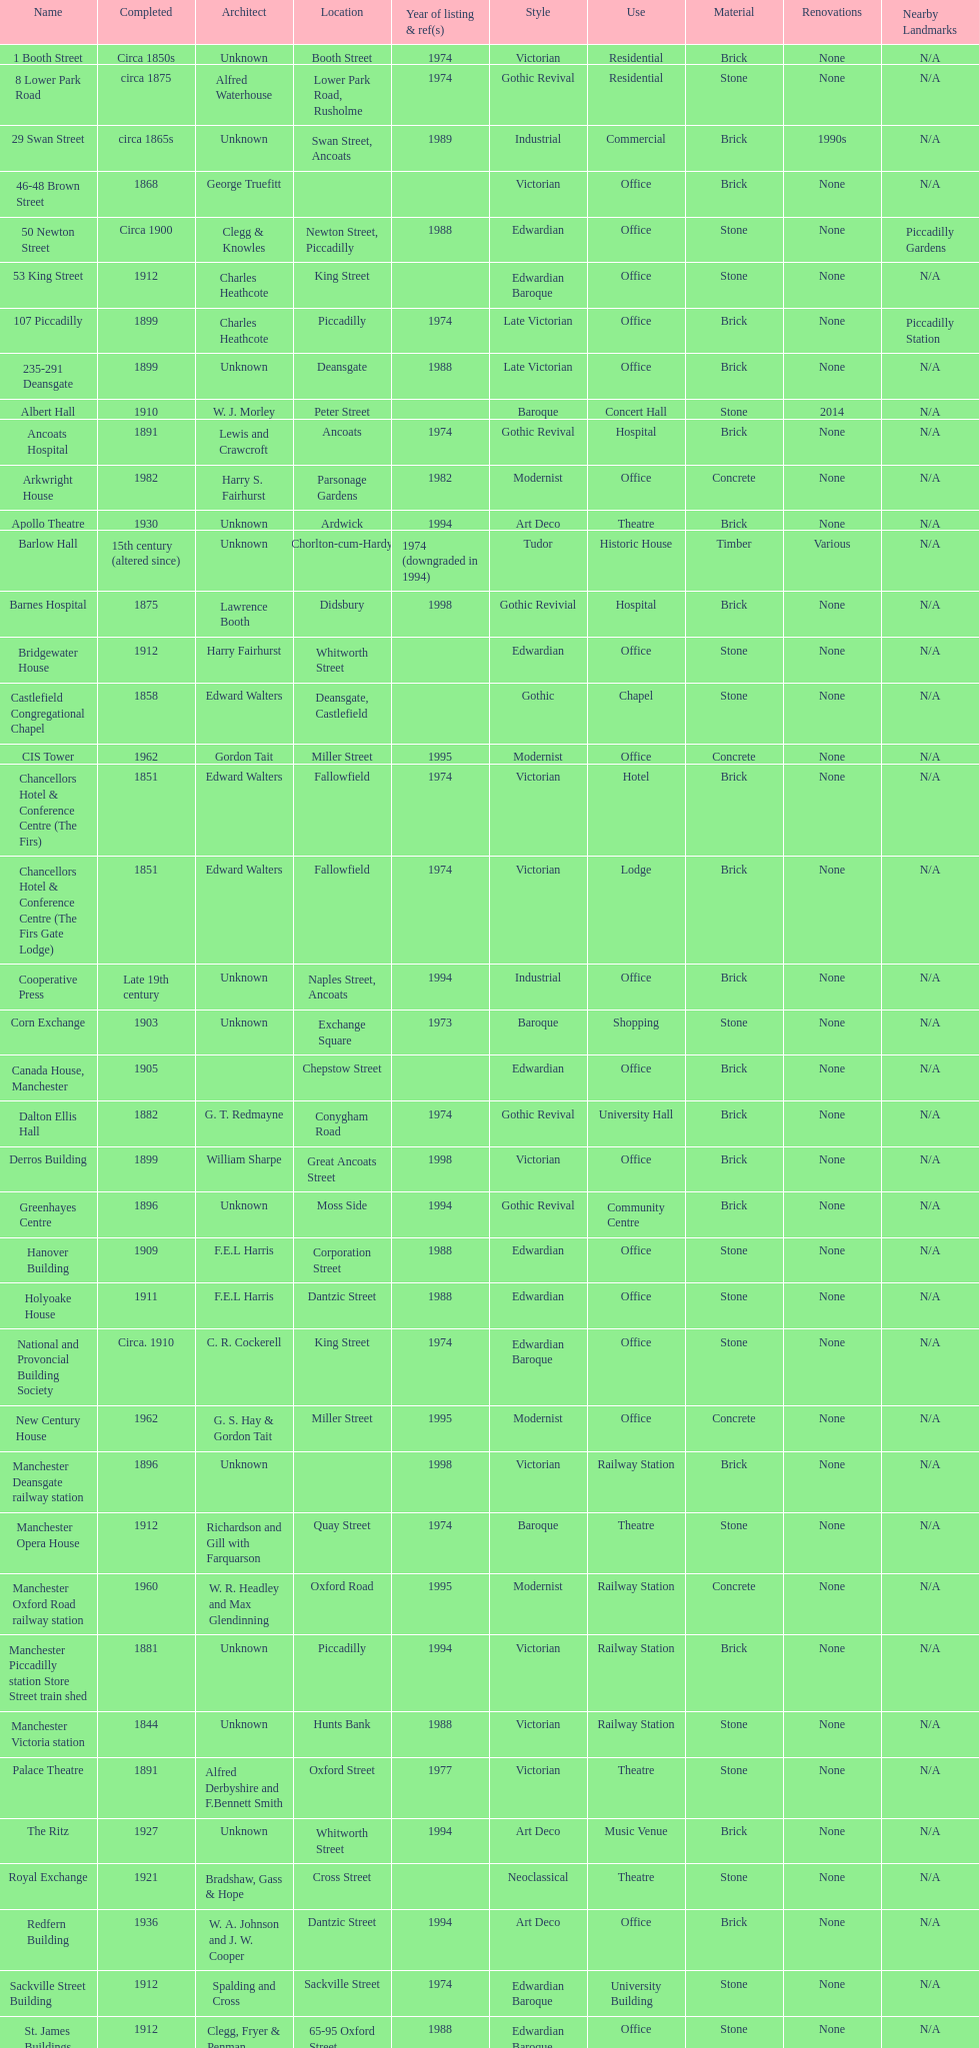How many names are listed with an image? 39. 